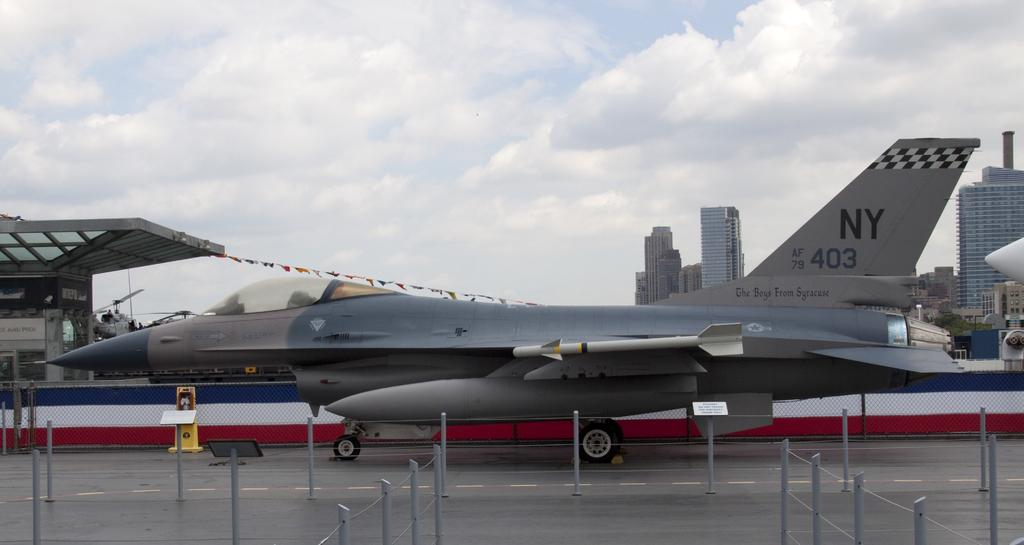<image>
Offer a succinct explanation of the picture presented. A silver fighter jet has the number NY 403 on the tail. 